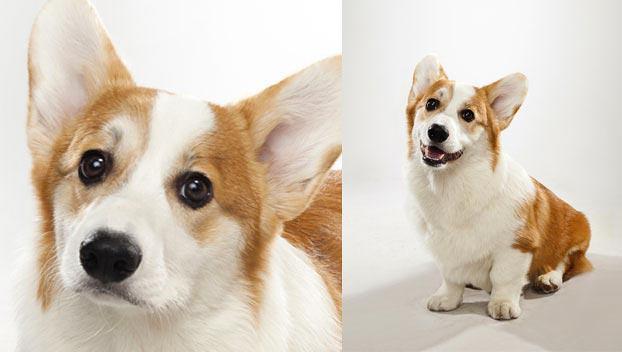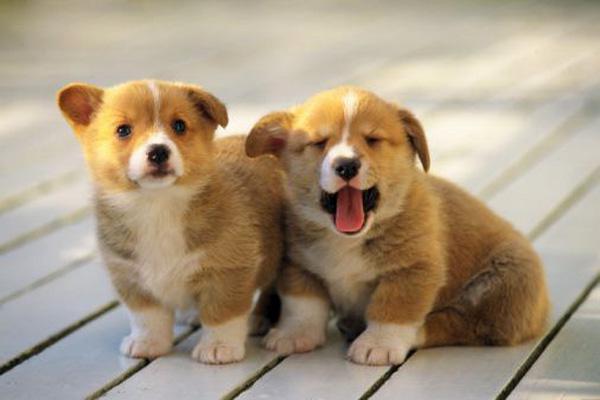The first image is the image on the left, the second image is the image on the right. Given the left and right images, does the statement "There are three dogs" hold true? Answer yes or no. No. The first image is the image on the left, the second image is the image on the right. Given the left and right images, does the statement "One image has exactly one dog." hold true? Answer yes or no. No. The first image is the image on the left, the second image is the image on the right. Considering the images on both sides, is "One dog is sitting and the other is laying flat with paws forward." valid? Answer yes or no. No. 